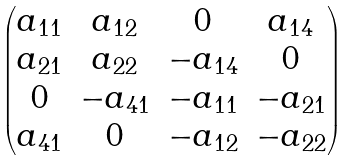Convert formula to latex. <formula><loc_0><loc_0><loc_500><loc_500>\begin{pmatrix} a _ { 1 1 } & a _ { 1 2 } & 0 & a _ { 1 4 } \\ a _ { 2 1 } & a _ { 2 2 } & - a _ { 1 4 } & 0 \\ 0 & - a _ { 4 1 } & - a _ { 1 1 } & - a _ { 2 1 } \\ a _ { 4 1 } & 0 & - a _ { 1 2 } & - a _ { 2 2 } \end{pmatrix}</formula> 